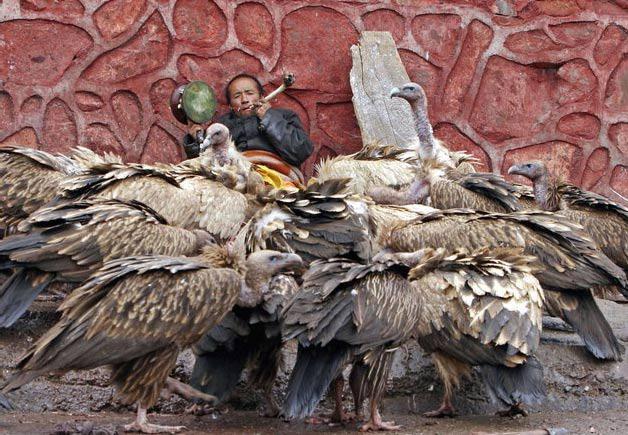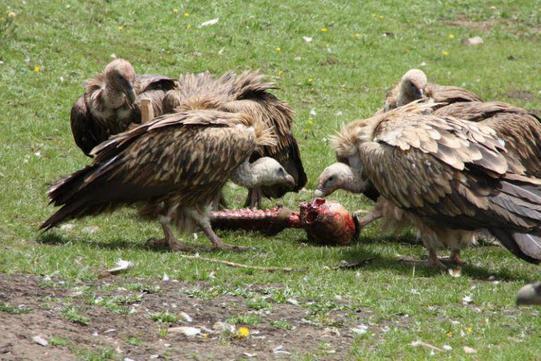The first image is the image on the left, the second image is the image on the right. Given the left and right images, does the statement "There is a human skeleton next to a group of vultures in one of the images." hold true? Answer yes or no. Yes. The first image is the image on the left, the second image is the image on the right. Evaluate the accuracy of this statement regarding the images: "In every image, the vultures are eating.". Is it true? Answer yes or no. No. 